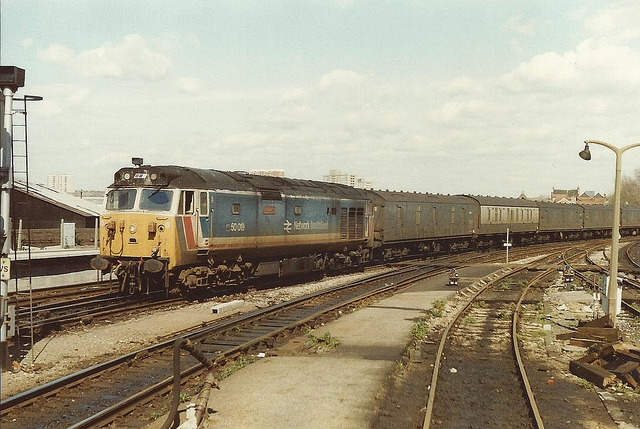Read all the text in this image. S 